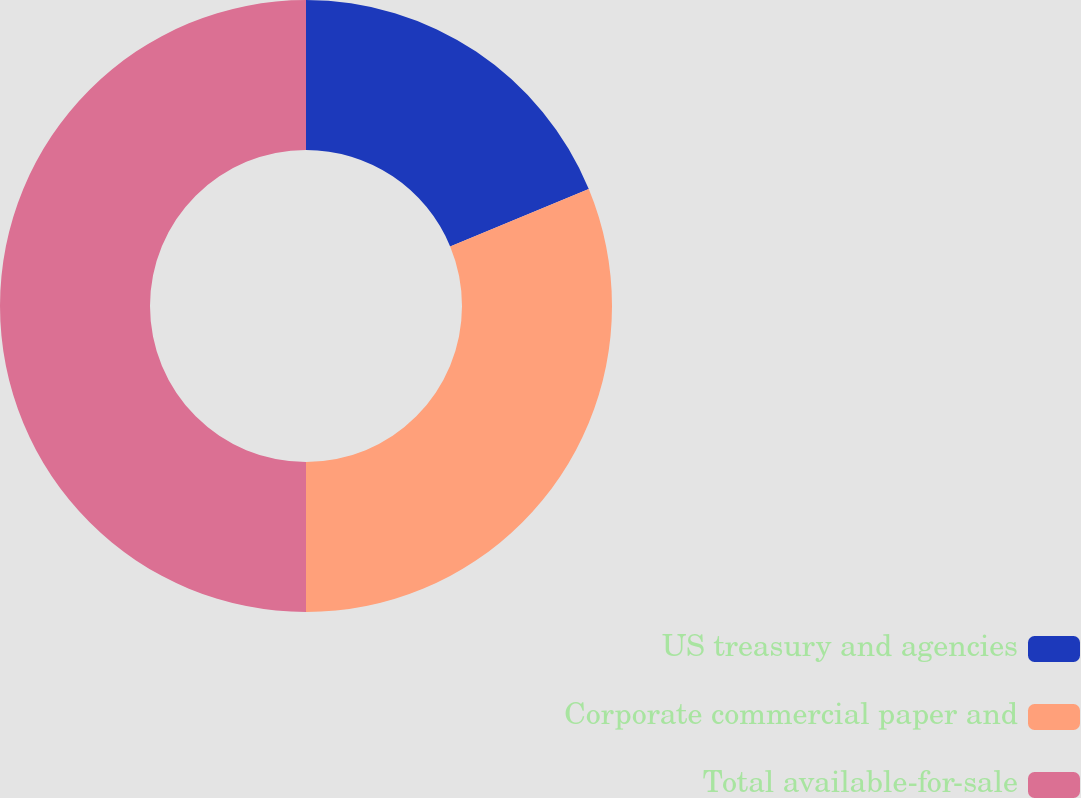<chart> <loc_0><loc_0><loc_500><loc_500><pie_chart><fcel>US treasury and agencies<fcel>Corporate commercial paper and<fcel>Total available-for-sale<nl><fcel>18.76%<fcel>31.24%<fcel>50.0%<nl></chart> 